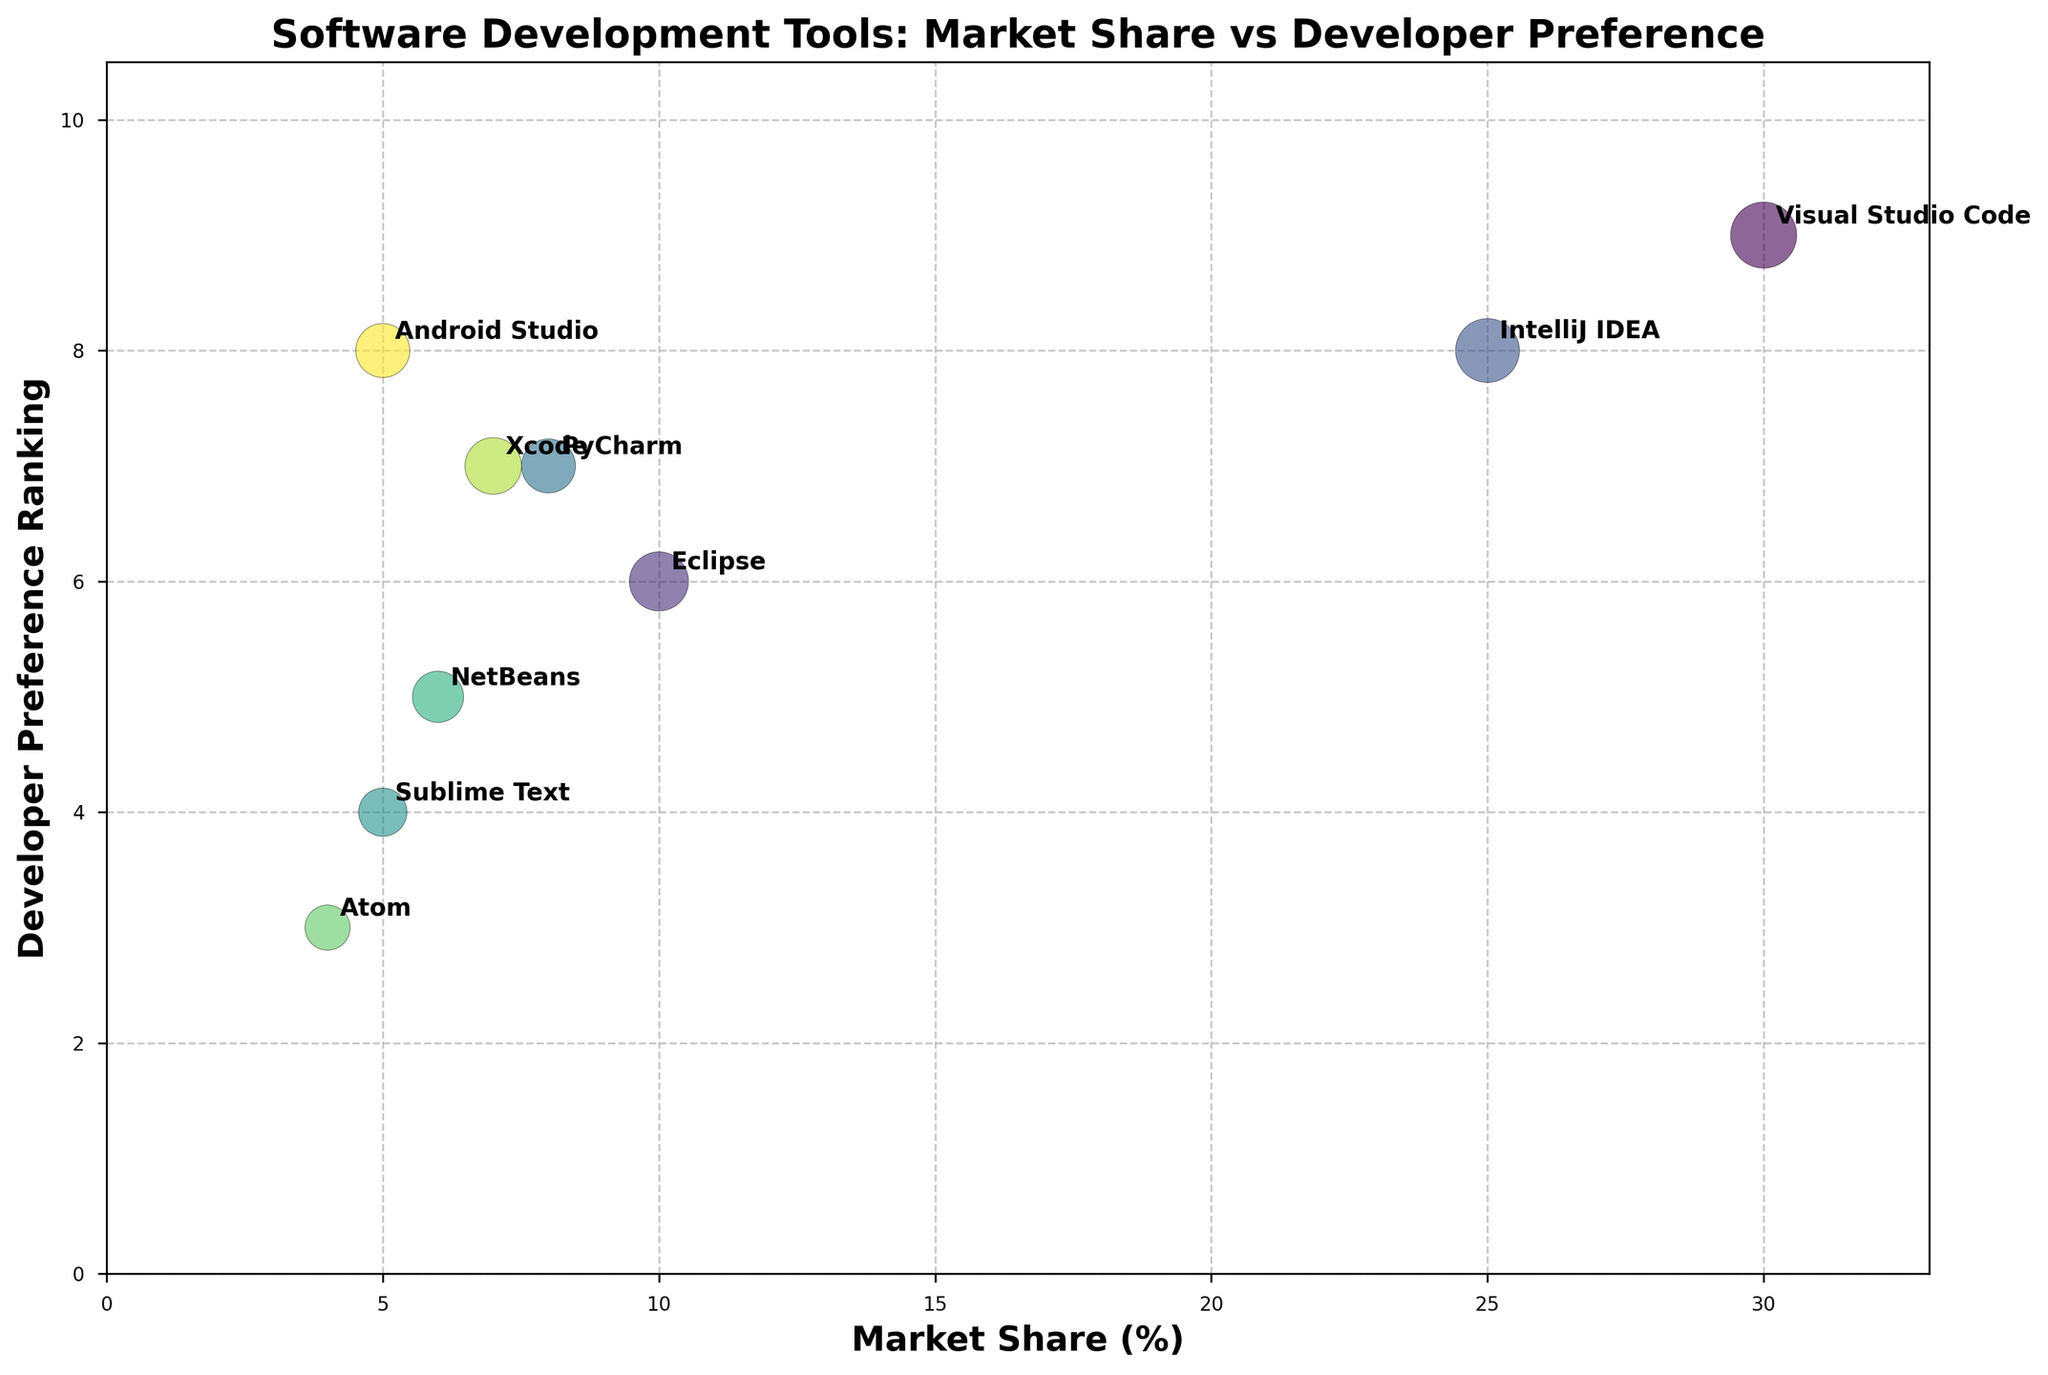What are the x and y-axis labels of the chart? The x-axis label is "Market Share (%)" which represents the percentage market share of each tool. The y-axis label is "Developer Preference Ranking" which shows the preference ranking given by developers, with values ranging from 1 to 10.
Answer: Market Share (%), Developer Preference Ranking How many software development tools are displayed in the chart? To answer this, count the number of distinct bubbles or check the number of annotated labels. In this case, there are nine different software development tools shown.
Answer: 9 Which tool has the highest market share? Identify the tool that has the bubble positioned furthest to the right. "Visual Studio Code" is positioned at a market share of 30%, which is the highest.
Answer: Visual Studio Code Which tool has the highest developer preference ranking? Look for the bubble positioned highest on the y-axis. "Visual Studio Code" has the highest preference ranking of 9.
Answer: Visual Studio Code What is the market share range covered by the tools? The lowest value on the x-axis is 4% (Atom), and the highest is 30% (Visual Studio Code). Therefore, the range is 30 - 4 = 26%.
Answer: 26% Ignoring bubble size, which tools have exactly the same developer preference ranking? Find the tools that are positioned at the same value on the y-axis. "PyCharm" and "Xcode" both have a developer preference ranking of 7.
Answer: PyCharm, Xcode What is the difference in market share between IntelliJ IDEA and NetBeans? Look at the Market Share (%) values for both IntelliJ IDEA (25%) and NetBeans (6%). The difference is 25 - 6 = 19%.
Answer: 19% Which tool has the largest bubble size, indicating the highest importance in the dataset? Visually compare bubble sizes. "Visual Studio Code" has the largest bubble size, with a value of 15 (scaled appropriately).
Answer: Visual Studio Code How does the market share of Eclipse compare to Atom? Compare the horizontal positions. Eclipse has a market share of 10%, and Atom has a market share of 4%. Hence, Eclipse has a larger market share.
Answer: Eclipse has a larger market share Which tool has the smallest bubble, and what is its market share? The smallest bubble visually is "Atom," and it has a market share of 4%.
Answer: Atom, 4% 